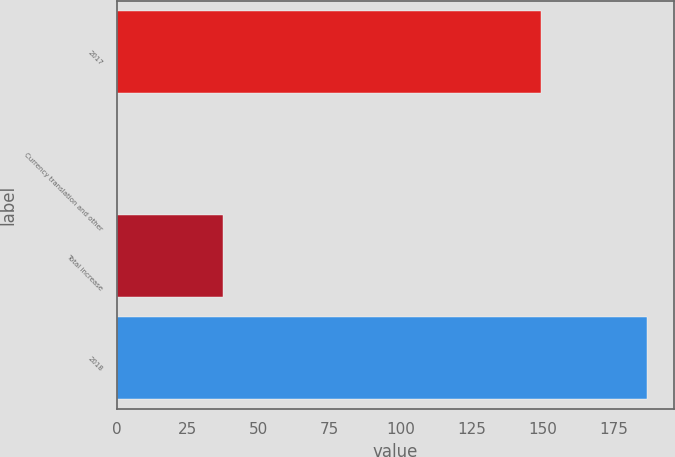<chart> <loc_0><loc_0><loc_500><loc_500><bar_chart><fcel>2017<fcel>Currency translation and other<fcel>Total increase<fcel>2018<nl><fcel>149.6<fcel>0.1<fcel>37.3<fcel>186.9<nl></chart> 